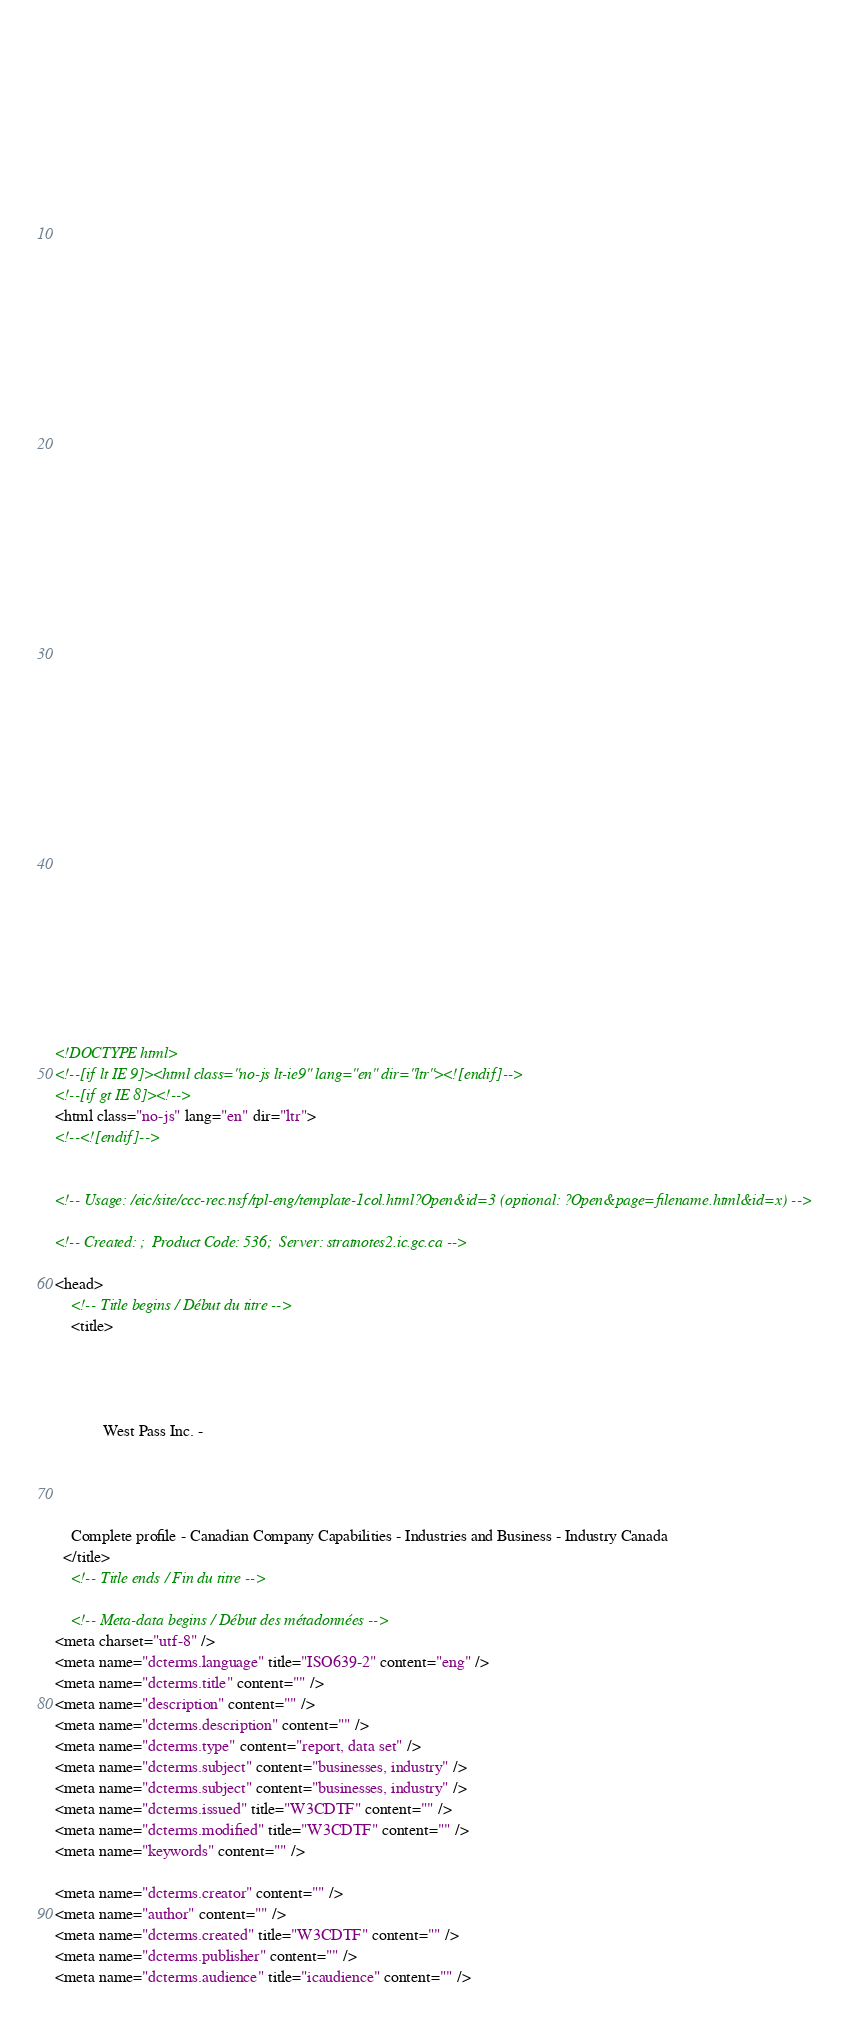<code> <loc_0><loc_0><loc_500><loc_500><_HTML_>


















	






  
  
  
  































	
	
	



<!DOCTYPE html>
<!--[if lt IE 9]><html class="no-js lt-ie9" lang="en" dir="ltr"><![endif]-->
<!--[if gt IE 8]><!-->
<html class="no-js" lang="en" dir="ltr">
<!--<![endif]-->


<!-- Usage: /eic/site/ccc-rec.nsf/tpl-eng/template-1col.html?Open&id=3 (optional: ?Open&page=filename.html&id=x) -->

<!-- Created: ;  Product Code: 536;  Server: stratnotes2.ic.gc.ca -->

<head>
	<!-- Title begins / Début du titre -->
	<title>
    
            
        
          
            West Pass Inc. -
          
        
      
    
    Complete profile - Canadian Company Capabilities - Industries and Business - Industry Canada
  </title>
	<!-- Title ends / Fin du titre -->
 
	<!-- Meta-data begins / Début des métadonnées -->
<meta charset="utf-8" />
<meta name="dcterms.language" title="ISO639-2" content="eng" />
<meta name="dcterms.title" content="" />
<meta name="description" content="" />
<meta name="dcterms.description" content="" />
<meta name="dcterms.type" content="report, data set" />
<meta name="dcterms.subject" content="businesses, industry" />
<meta name="dcterms.subject" content="businesses, industry" />
<meta name="dcterms.issued" title="W3CDTF" content="" />
<meta name="dcterms.modified" title="W3CDTF" content="" />
<meta name="keywords" content="" />

<meta name="dcterms.creator" content="" />
<meta name="author" content="" />
<meta name="dcterms.created" title="W3CDTF" content="" />
<meta name="dcterms.publisher" content="" />
<meta name="dcterms.audience" title="icaudience" content="" /></code> 